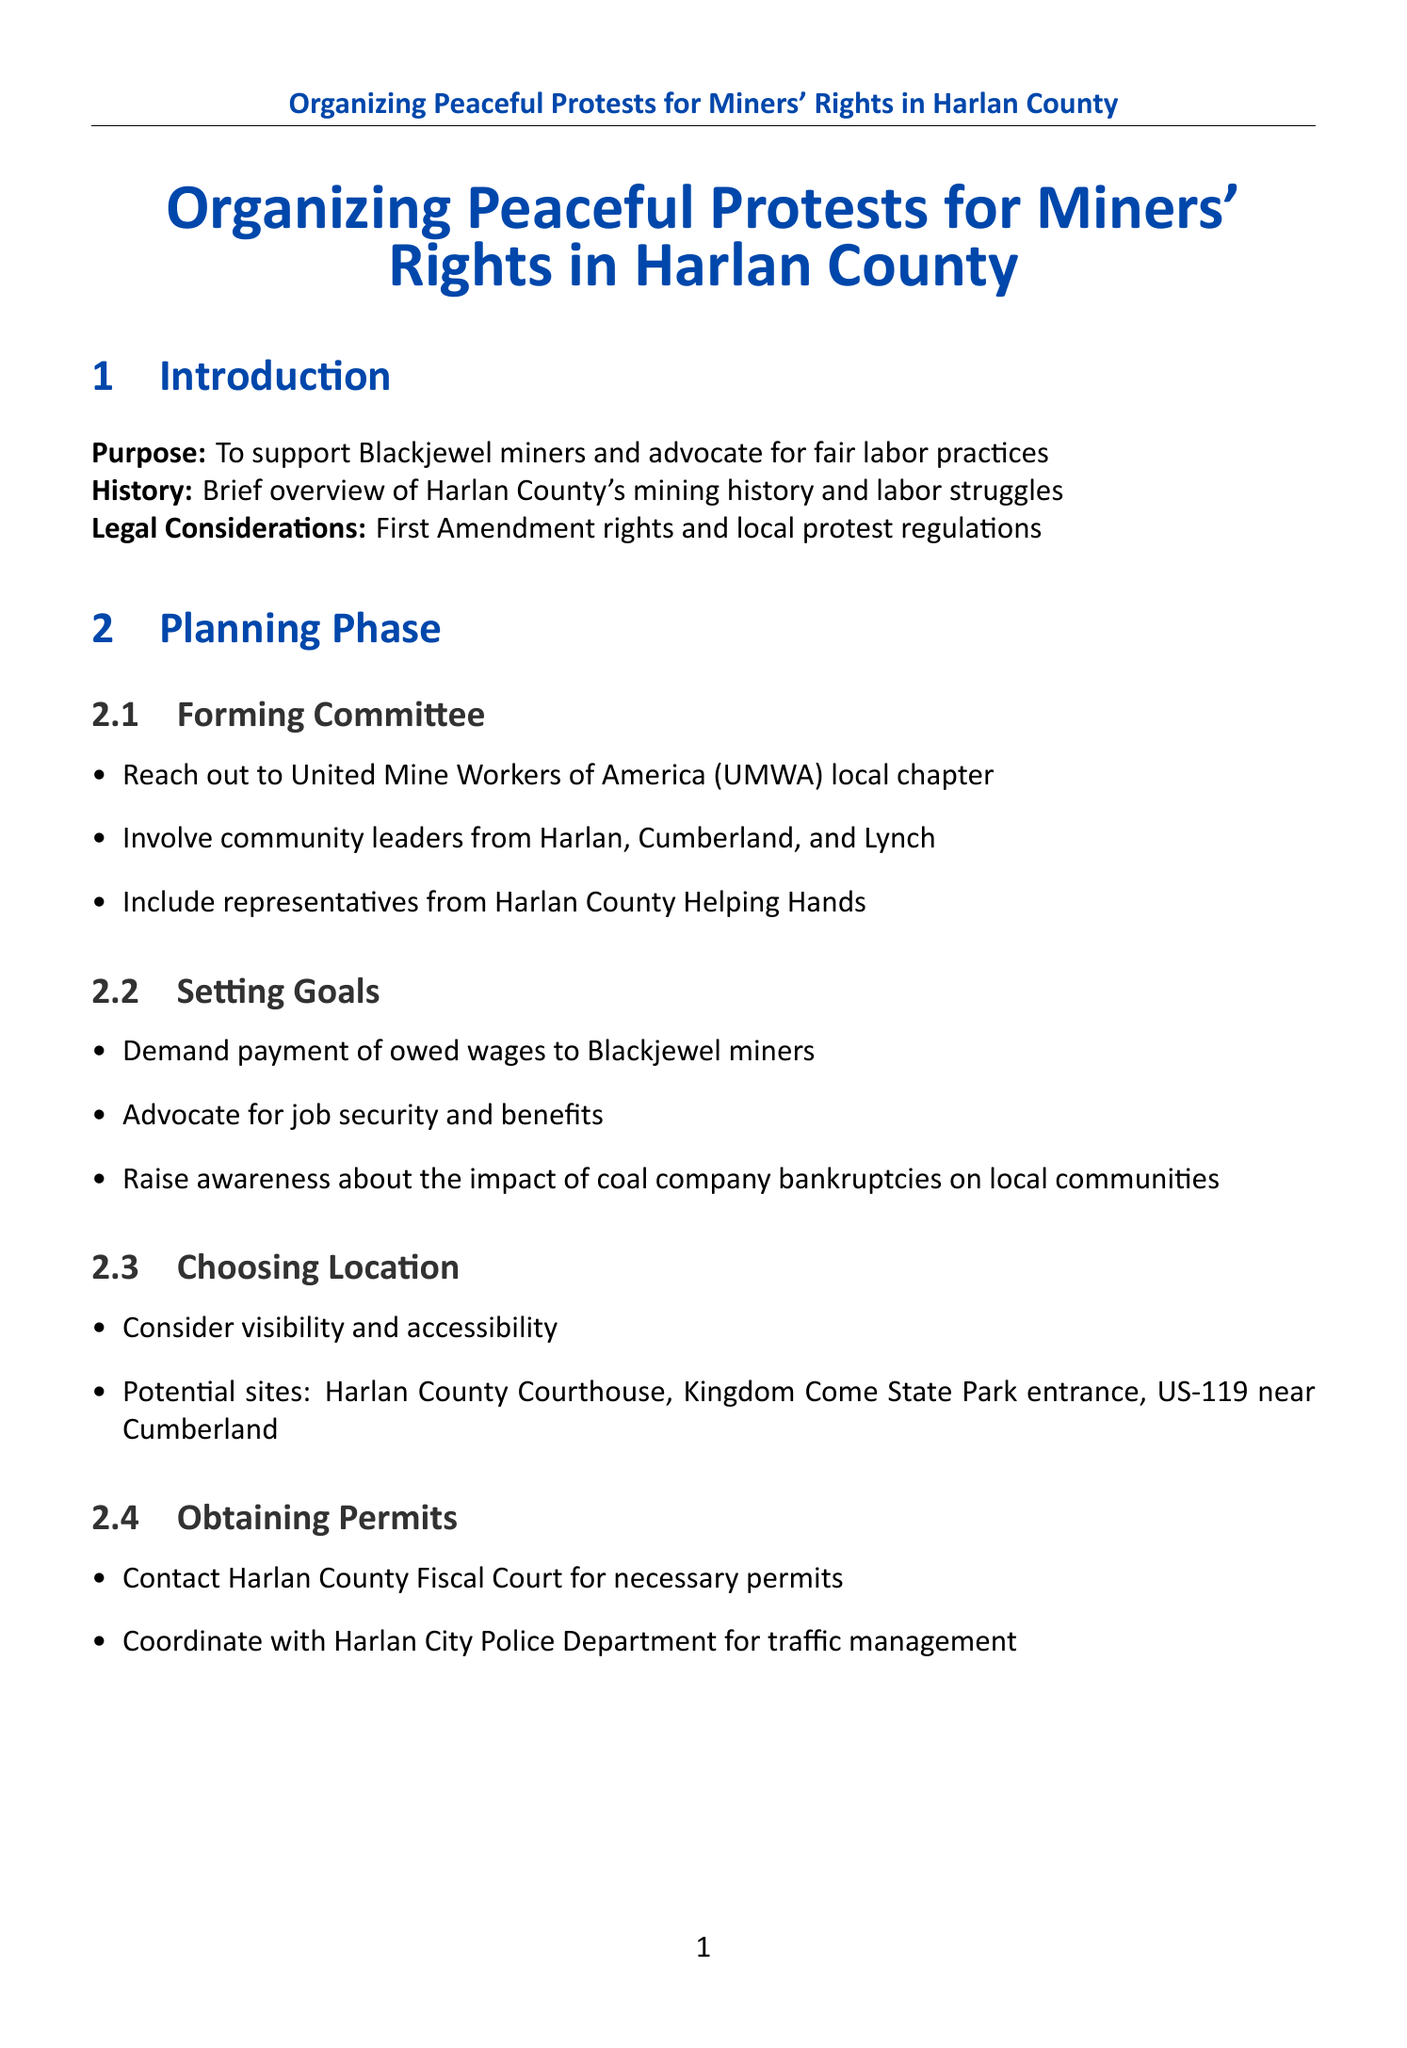What is the purpose of the document? The purpose is to support Blackjewel miners and advocate for fair labor practices.
Answer: To support Blackjewel miners and advocate for fair labor practices Which organization should be contacted for forming a committee? The committee should reach out to the United Mine Workers of America local chapter.
Answer: United Mine Workers of America (UMWA) What locations are suggested for the protest? Suggested sites include the Harlan County Courthouse, Kingdom Come State Park entrance, and US-119 near Cumberland.
Answer: Harlan County Courthouse, Kingdom Come State Park entrance, US-119 near Cumberland What type of outreach involves sending press releases? Media outreach involves sending press releases to local media outlets.
Answer: Media outreach How many safety measures are listed in the guidelines? There are three safety measures listed in the document.
Answer: Three What strategy can be used to maintain community engagement? Distributing flyers at local businesses is a strategy for community engagement.
Answer: Distribute flyers at local businesses What type of system should be established for protesters? A buddy system should be established for protesters.
Answer: Buddy system What is a follow-up action mentioned for maintaining momentum? Establishing a Harlan County Miners' Support Network is a follow-up action.
Answer: Harlan County Miners' Support Network What is one goal of the protest? One goal is to demand payment of owed wages to Blackjewel miners.
Answer: Demand payment of owed wages to Blackjewel miners 